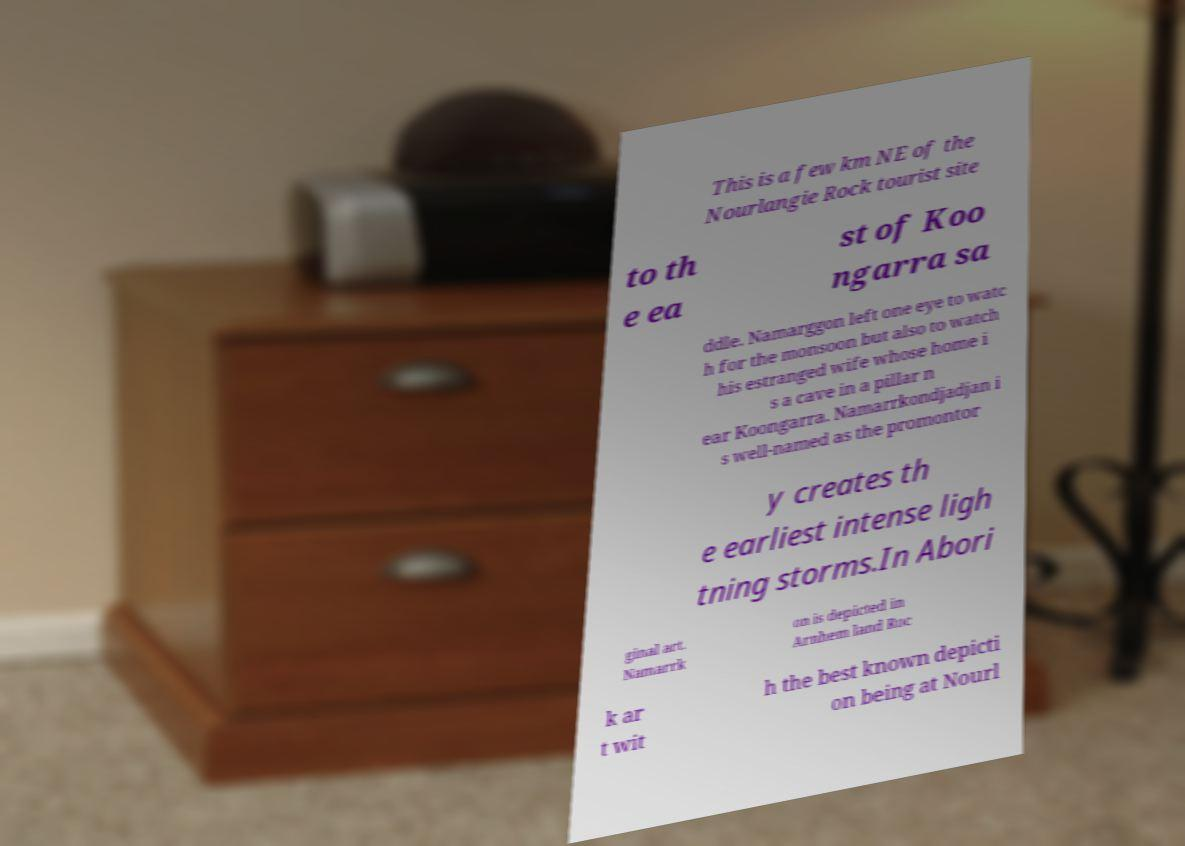I need the written content from this picture converted into text. Can you do that? This is a few km NE of the Nourlangie Rock tourist site to th e ea st of Koo ngarra sa ddle. Namarggon left one eye to watc h for the monsoon but also to watch his estranged wife whose home i s a cave in a pillar n ear Koongarra. Namarrkondjadjan i s well-named as the promontor y creates th e earliest intense ligh tning storms.In Abori ginal art. Namarrk on is depicted in Arnhem land Roc k ar t wit h the best known depicti on being at Nourl 